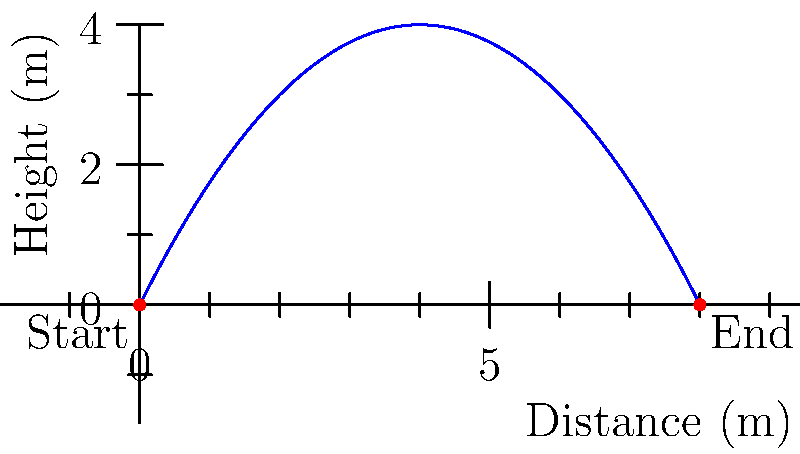An athlete's long jump trajectory can be modeled by the parabolic function $h(x) = -0.25x^2 + 2x$, where $h$ is the height in meters and $x$ is the horizontal distance in meters. What is the total horizontal distance covered by the athlete during this jump? To find the total horizontal distance covered by the athlete, we need to determine where the parabola intersects the x-axis (ground level). This occurs at two points: the starting point and the landing point.

1) At the starting point, $x = 0$ and $h(0) = 0$.

2) For the landing point, we need to solve the equation:
   $h(x) = 0$
   $-0.25x^2 + 2x = 0$

3) Factor out the common factor:
   $x(-0.25x + 2) = 0$

4) Solve the equation:
   $x = 0$ or $-0.25x + 2 = 0$
   
   For the second part:
   $-0.25x = -2$
   $x = 8$

5) The solutions are $x = 0$ and $x = 8$.

6) Since $x = 0$ is the starting point, $x = 8$ must be the landing point.

Therefore, the total horizontal distance covered by the athlete is 8 meters.
Answer: 8 meters 